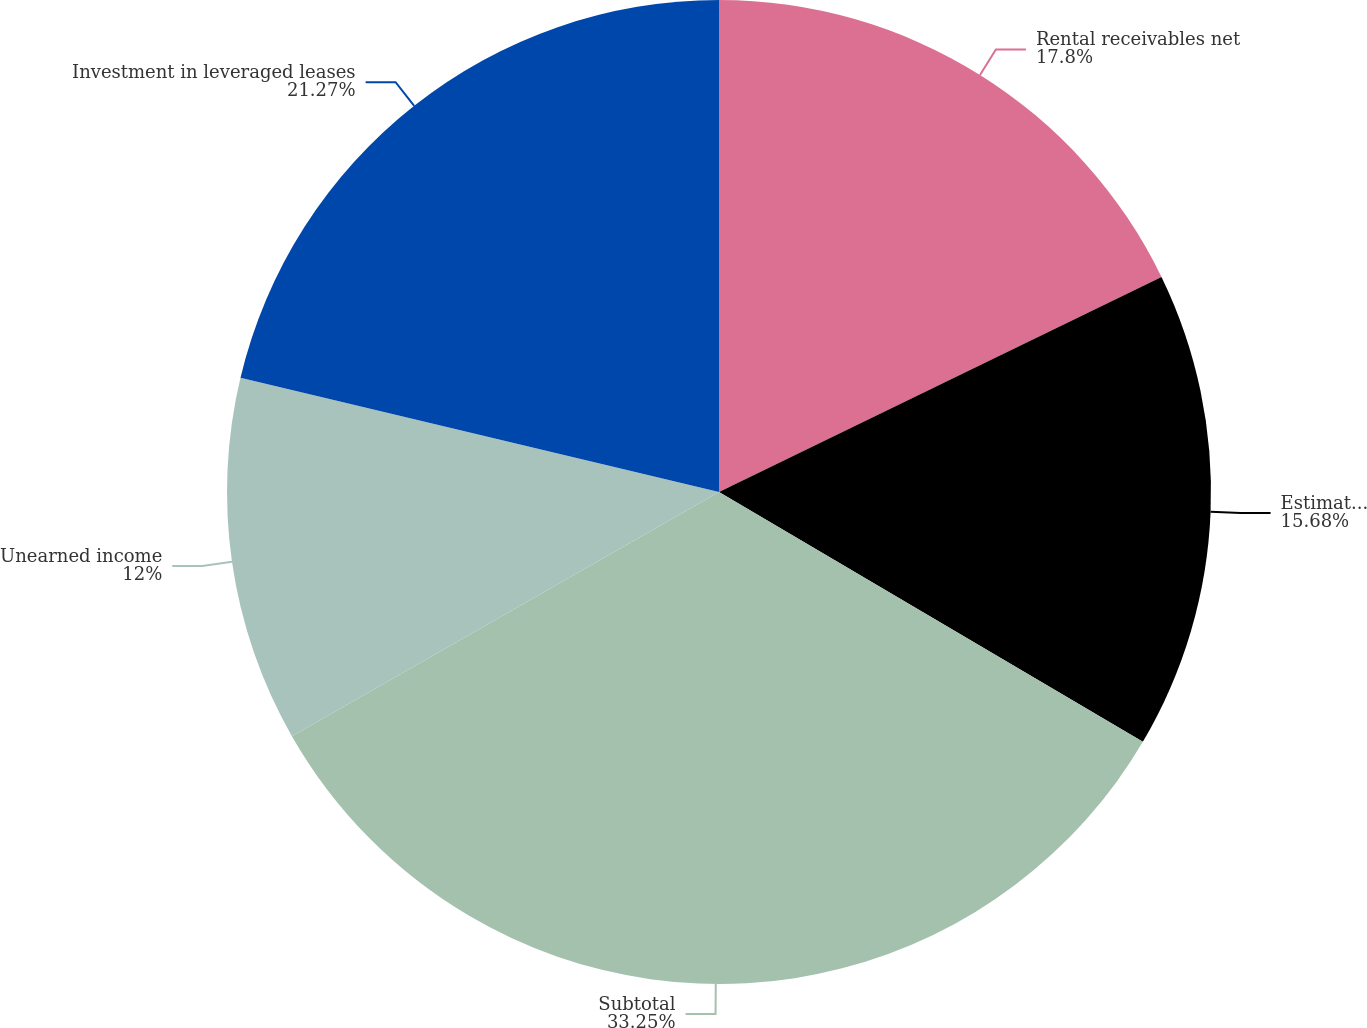Convert chart to OTSL. <chart><loc_0><loc_0><loc_500><loc_500><pie_chart><fcel>Rental receivables net<fcel>Estimated residual values<fcel>Subtotal<fcel>Unearned income<fcel>Investment in leveraged leases<nl><fcel>17.8%<fcel>15.68%<fcel>33.26%<fcel>12.0%<fcel>21.27%<nl></chart> 